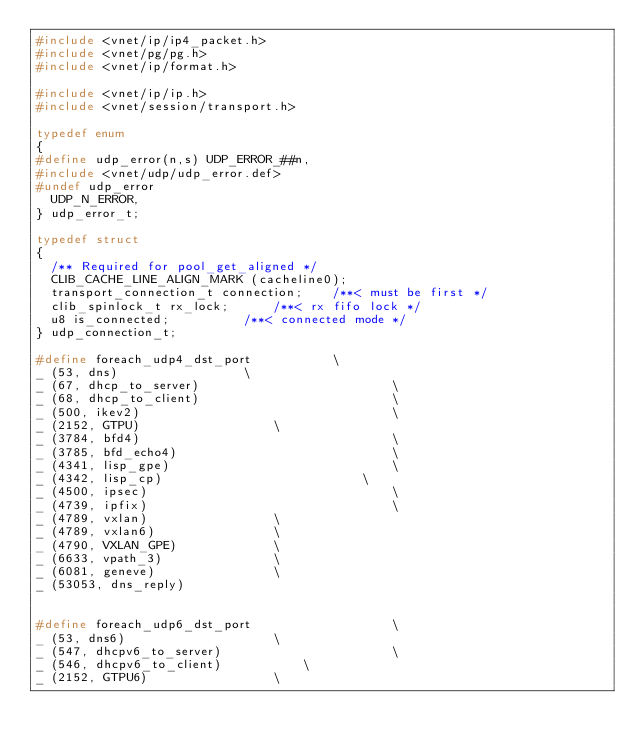Convert code to text. <code><loc_0><loc_0><loc_500><loc_500><_C_>#include <vnet/ip/ip4_packet.h>
#include <vnet/pg/pg.h>
#include <vnet/ip/format.h>

#include <vnet/ip/ip.h>
#include <vnet/session/transport.h>

typedef enum
{
#define udp_error(n,s) UDP_ERROR_##n,
#include <vnet/udp/udp_error.def>
#undef udp_error
  UDP_N_ERROR,
} udp_error_t;

typedef struct
{
  /** Required for pool_get_aligned */
  CLIB_CACHE_LINE_ALIGN_MARK (cacheline0);
  transport_connection_t connection;	/**< must be first */
  clib_spinlock_t rx_lock;		/**< rx fifo lock */
  u8 is_connected;			/**< connected mode */
} udp_connection_t;

#define foreach_udp4_dst_port			\
_ (53, dns)					\
_ (67, dhcp_to_server)                          \
_ (68, dhcp_to_client)                          \
_ (500, ikev2)                                  \
_ (2152, GTPU)					\
_ (3784, bfd4)                                  \
_ (3785, bfd_echo4)                             \
_ (4341, lisp_gpe)                              \
_ (4342, lisp_cp)                          	\
_ (4500, ipsec)                                 \
_ (4739, ipfix)                                 \
_ (4789, vxlan)					\
_ (4789, vxlan6)				\
_ (4790, VXLAN_GPE)				\
_ (6633, vpath_3)				\
_ (6081, geneve)				\
_ (53053, dns_reply)


#define foreach_udp6_dst_port                   \
_ (53, dns6)					\
_ (547, dhcpv6_to_server)                       \
_ (546, dhcpv6_to_client)			\
_ (2152, GTPU6)					\</code> 